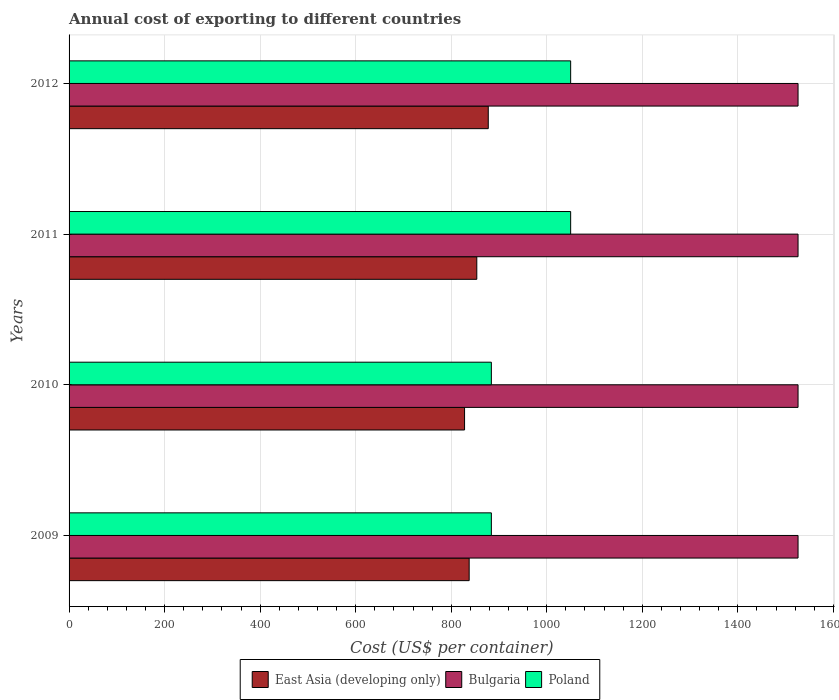How many groups of bars are there?
Offer a very short reply. 4. How many bars are there on the 1st tick from the top?
Your answer should be very brief. 3. What is the label of the 1st group of bars from the top?
Give a very brief answer. 2012. What is the total annual cost of exporting in Poland in 2011?
Offer a terse response. 1050. Across all years, what is the maximum total annual cost of exporting in Bulgaria?
Give a very brief answer. 1526. Across all years, what is the minimum total annual cost of exporting in Bulgaria?
Your answer should be very brief. 1526. In which year was the total annual cost of exporting in East Asia (developing only) minimum?
Ensure brevity in your answer.  2010. What is the total total annual cost of exporting in Bulgaria in the graph?
Keep it short and to the point. 6104. What is the difference between the total annual cost of exporting in East Asia (developing only) in 2011 and that in 2012?
Give a very brief answer. -24.02. What is the difference between the total annual cost of exporting in Poland in 2011 and the total annual cost of exporting in Bulgaria in 2012?
Keep it short and to the point. -476. What is the average total annual cost of exporting in Poland per year?
Provide a succinct answer. 967. In the year 2009, what is the difference between the total annual cost of exporting in Bulgaria and total annual cost of exporting in Poland?
Your response must be concise. 642. In how many years, is the total annual cost of exporting in Poland greater than 1000 US$?
Your answer should be very brief. 2. What is the ratio of the total annual cost of exporting in Poland in 2010 to that in 2011?
Your answer should be very brief. 0.84. Is the difference between the total annual cost of exporting in Bulgaria in 2010 and 2012 greater than the difference between the total annual cost of exporting in Poland in 2010 and 2012?
Your answer should be compact. Yes. What is the difference between the highest and the second highest total annual cost of exporting in East Asia (developing only)?
Offer a terse response. 24.02. What is the difference between the highest and the lowest total annual cost of exporting in Poland?
Ensure brevity in your answer.  166. In how many years, is the total annual cost of exporting in Poland greater than the average total annual cost of exporting in Poland taken over all years?
Your answer should be very brief. 2. Is the sum of the total annual cost of exporting in East Asia (developing only) in 2011 and 2012 greater than the maximum total annual cost of exporting in Poland across all years?
Ensure brevity in your answer.  Yes. What does the 2nd bar from the top in 2011 represents?
Keep it short and to the point. Bulgaria. What does the 1st bar from the bottom in 2012 represents?
Give a very brief answer. East Asia (developing only). Is it the case that in every year, the sum of the total annual cost of exporting in Bulgaria and total annual cost of exporting in Poland is greater than the total annual cost of exporting in East Asia (developing only)?
Ensure brevity in your answer.  Yes. How many bars are there?
Ensure brevity in your answer.  12. Does the graph contain any zero values?
Your answer should be compact. No. Where does the legend appear in the graph?
Provide a succinct answer. Bottom center. How many legend labels are there?
Give a very brief answer. 3. What is the title of the graph?
Ensure brevity in your answer.  Annual cost of exporting to different countries. What is the label or title of the X-axis?
Ensure brevity in your answer.  Cost (US$ per container). What is the Cost (US$ per container) of East Asia (developing only) in 2009?
Your response must be concise. 837.55. What is the Cost (US$ per container) in Bulgaria in 2009?
Make the answer very short. 1526. What is the Cost (US$ per container) of Poland in 2009?
Ensure brevity in your answer.  884. What is the Cost (US$ per container) of East Asia (developing only) in 2010?
Offer a terse response. 827.9. What is the Cost (US$ per container) in Bulgaria in 2010?
Make the answer very short. 1526. What is the Cost (US$ per container) of Poland in 2010?
Give a very brief answer. 884. What is the Cost (US$ per container) in East Asia (developing only) in 2011?
Offer a terse response. 853.5. What is the Cost (US$ per container) in Bulgaria in 2011?
Ensure brevity in your answer.  1526. What is the Cost (US$ per container) in Poland in 2011?
Your answer should be compact. 1050. What is the Cost (US$ per container) of East Asia (developing only) in 2012?
Your answer should be compact. 877.52. What is the Cost (US$ per container) of Bulgaria in 2012?
Offer a very short reply. 1526. What is the Cost (US$ per container) of Poland in 2012?
Keep it short and to the point. 1050. Across all years, what is the maximum Cost (US$ per container) in East Asia (developing only)?
Give a very brief answer. 877.52. Across all years, what is the maximum Cost (US$ per container) in Bulgaria?
Offer a terse response. 1526. Across all years, what is the maximum Cost (US$ per container) of Poland?
Offer a terse response. 1050. Across all years, what is the minimum Cost (US$ per container) in East Asia (developing only)?
Keep it short and to the point. 827.9. Across all years, what is the minimum Cost (US$ per container) in Bulgaria?
Your answer should be very brief. 1526. Across all years, what is the minimum Cost (US$ per container) in Poland?
Offer a very short reply. 884. What is the total Cost (US$ per container) in East Asia (developing only) in the graph?
Provide a succinct answer. 3396.47. What is the total Cost (US$ per container) of Bulgaria in the graph?
Offer a very short reply. 6104. What is the total Cost (US$ per container) in Poland in the graph?
Give a very brief answer. 3868. What is the difference between the Cost (US$ per container) of East Asia (developing only) in 2009 and that in 2010?
Offer a terse response. 9.65. What is the difference between the Cost (US$ per container) in Bulgaria in 2009 and that in 2010?
Offer a very short reply. 0. What is the difference between the Cost (US$ per container) in East Asia (developing only) in 2009 and that in 2011?
Your answer should be very brief. -15.95. What is the difference between the Cost (US$ per container) of Bulgaria in 2009 and that in 2011?
Offer a very short reply. 0. What is the difference between the Cost (US$ per container) in Poland in 2009 and that in 2011?
Provide a short and direct response. -166. What is the difference between the Cost (US$ per container) in East Asia (developing only) in 2009 and that in 2012?
Provide a succinct answer. -39.97. What is the difference between the Cost (US$ per container) in Bulgaria in 2009 and that in 2012?
Offer a very short reply. 0. What is the difference between the Cost (US$ per container) of Poland in 2009 and that in 2012?
Keep it short and to the point. -166. What is the difference between the Cost (US$ per container) in East Asia (developing only) in 2010 and that in 2011?
Give a very brief answer. -25.6. What is the difference between the Cost (US$ per container) in Poland in 2010 and that in 2011?
Provide a succinct answer. -166. What is the difference between the Cost (US$ per container) in East Asia (developing only) in 2010 and that in 2012?
Provide a succinct answer. -49.62. What is the difference between the Cost (US$ per container) of Poland in 2010 and that in 2012?
Keep it short and to the point. -166. What is the difference between the Cost (US$ per container) of East Asia (developing only) in 2011 and that in 2012?
Ensure brevity in your answer.  -24.02. What is the difference between the Cost (US$ per container) in East Asia (developing only) in 2009 and the Cost (US$ per container) in Bulgaria in 2010?
Ensure brevity in your answer.  -688.45. What is the difference between the Cost (US$ per container) in East Asia (developing only) in 2009 and the Cost (US$ per container) in Poland in 2010?
Offer a very short reply. -46.45. What is the difference between the Cost (US$ per container) of Bulgaria in 2009 and the Cost (US$ per container) of Poland in 2010?
Keep it short and to the point. 642. What is the difference between the Cost (US$ per container) in East Asia (developing only) in 2009 and the Cost (US$ per container) in Bulgaria in 2011?
Your response must be concise. -688.45. What is the difference between the Cost (US$ per container) in East Asia (developing only) in 2009 and the Cost (US$ per container) in Poland in 2011?
Give a very brief answer. -212.45. What is the difference between the Cost (US$ per container) of Bulgaria in 2009 and the Cost (US$ per container) of Poland in 2011?
Keep it short and to the point. 476. What is the difference between the Cost (US$ per container) in East Asia (developing only) in 2009 and the Cost (US$ per container) in Bulgaria in 2012?
Give a very brief answer. -688.45. What is the difference between the Cost (US$ per container) in East Asia (developing only) in 2009 and the Cost (US$ per container) in Poland in 2012?
Provide a succinct answer. -212.45. What is the difference between the Cost (US$ per container) in Bulgaria in 2009 and the Cost (US$ per container) in Poland in 2012?
Ensure brevity in your answer.  476. What is the difference between the Cost (US$ per container) in East Asia (developing only) in 2010 and the Cost (US$ per container) in Bulgaria in 2011?
Provide a succinct answer. -698.1. What is the difference between the Cost (US$ per container) of East Asia (developing only) in 2010 and the Cost (US$ per container) of Poland in 2011?
Give a very brief answer. -222.1. What is the difference between the Cost (US$ per container) in Bulgaria in 2010 and the Cost (US$ per container) in Poland in 2011?
Give a very brief answer. 476. What is the difference between the Cost (US$ per container) of East Asia (developing only) in 2010 and the Cost (US$ per container) of Bulgaria in 2012?
Offer a very short reply. -698.1. What is the difference between the Cost (US$ per container) in East Asia (developing only) in 2010 and the Cost (US$ per container) in Poland in 2012?
Provide a succinct answer. -222.1. What is the difference between the Cost (US$ per container) in Bulgaria in 2010 and the Cost (US$ per container) in Poland in 2012?
Keep it short and to the point. 476. What is the difference between the Cost (US$ per container) of East Asia (developing only) in 2011 and the Cost (US$ per container) of Bulgaria in 2012?
Keep it short and to the point. -672.5. What is the difference between the Cost (US$ per container) of East Asia (developing only) in 2011 and the Cost (US$ per container) of Poland in 2012?
Your answer should be very brief. -196.5. What is the difference between the Cost (US$ per container) in Bulgaria in 2011 and the Cost (US$ per container) in Poland in 2012?
Offer a terse response. 476. What is the average Cost (US$ per container) in East Asia (developing only) per year?
Keep it short and to the point. 849.12. What is the average Cost (US$ per container) of Bulgaria per year?
Your answer should be very brief. 1526. What is the average Cost (US$ per container) of Poland per year?
Offer a very short reply. 967. In the year 2009, what is the difference between the Cost (US$ per container) in East Asia (developing only) and Cost (US$ per container) in Bulgaria?
Provide a short and direct response. -688.45. In the year 2009, what is the difference between the Cost (US$ per container) of East Asia (developing only) and Cost (US$ per container) of Poland?
Provide a short and direct response. -46.45. In the year 2009, what is the difference between the Cost (US$ per container) in Bulgaria and Cost (US$ per container) in Poland?
Your response must be concise. 642. In the year 2010, what is the difference between the Cost (US$ per container) of East Asia (developing only) and Cost (US$ per container) of Bulgaria?
Your answer should be compact. -698.1. In the year 2010, what is the difference between the Cost (US$ per container) of East Asia (developing only) and Cost (US$ per container) of Poland?
Keep it short and to the point. -56.1. In the year 2010, what is the difference between the Cost (US$ per container) in Bulgaria and Cost (US$ per container) in Poland?
Offer a terse response. 642. In the year 2011, what is the difference between the Cost (US$ per container) of East Asia (developing only) and Cost (US$ per container) of Bulgaria?
Your answer should be compact. -672.5. In the year 2011, what is the difference between the Cost (US$ per container) of East Asia (developing only) and Cost (US$ per container) of Poland?
Your response must be concise. -196.5. In the year 2011, what is the difference between the Cost (US$ per container) in Bulgaria and Cost (US$ per container) in Poland?
Provide a succinct answer. 476. In the year 2012, what is the difference between the Cost (US$ per container) in East Asia (developing only) and Cost (US$ per container) in Bulgaria?
Ensure brevity in your answer.  -648.48. In the year 2012, what is the difference between the Cost (US$ per container) of East Asia (developing only) and Cost (US$ per container) of Poland?
Keep it short and to the point. -172.48. In the year 2012, what is the difference between the Cost (US$ per container) of Bulgaria and Cost (US$ per container) of Poland?
Ensure brevity in your answer.  476. What is the ratio of the Cost (US$ per container) in East Asia (developing only) in 2009 to that in 2010?
Your response must be concise. 1.01. What is the ratio of the Cost (US$ per container) in Bulgaria in 2009 to that in 2010?
Provide a short and direct response. 1. What is the ratio of the Cost (US$ per container) of Poland in 2009 to that in 2010?
Offer a very short reply. 1. What is the ratio of the Cost (US$ per container) of East Asia (developing only) in 2009 to that in 2011?
Offer a very short reply. 0.98. What is the ratio of the Cost (US$ per container) of Bulgaria in 2009 to that in 2011?
Make the answer very short. 1. What is the ratio of the Cost (US$ per container) of Poland in 2009 to that in 2011?
Make the answer very short. 0.84. What is the ratio of the Cost (US$ per container) in East Asia (developing only) in 2009 to that in 2012?
Keep it short and to the point. 0.95. What is the ratio of the Cost (US$ per container) in Poland in 2009 to that in 2012?
Provide a short and direct response. 0.84. What is the ratio of the Cost (US$ per container) of Bulgaria in 2010 to that in 2011?
Offer a terse response. 1. What is the ratio of the Cost (US$ per container) of Poland in 2010 to that in 2011?
Provide a short and direct response. 0.84. What is the ratio of the Cost (US$ per container) in East Asia (developing only) in 2010 to that in 2012?
Provide a short and direct response. 0.94. What is the ratio of the Cost (US$ per container) in Poland in 2010 to that in 2012?
Make the answer very short. 0.84. What is the ratio of the Cost (US$ per container) in East Asia (developing only) in 2011 to that in 2012?
Give a very brief answer. 0.97. What is the ratio of the Cost (US$ per container) of Poland in 2011 to that in 2012?
Keep it short and to the point. 1. What is the difference between the highest and the second highest Cost (US$ per container) of East Asia (developing only)?
Provide a succinct answer. 24.02. What is the difference between the highest and the second highest Cost (US$ per container) of Poland?
Your answer should be compact. 0. What is the difference between the highest and the lowest Cost (US$ per container) in East Asia (developing only)?
Keep it short and to the point. 49.62. What is the difference between the highest and the lowest Cost (US$ per container) in Bulgaria?
Your answer should be very brief. 0. What is the difference between the highest and the lowest Cost (US$ per container) of Poland?
Ensure brevity in your answer.  166. 